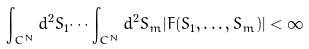<formula> <loc_0><loc_0><loc_500><loc_500>\int _ { C ^ { N } } d ^ { 2 } { S } _ { 1 } \dots \int _ { C ^ { N } } d ^ { 2 } { S } _ { m } | F ( { S _ { 1 } } , \dots , { S _ { m } } ) | < \infty</formula> 